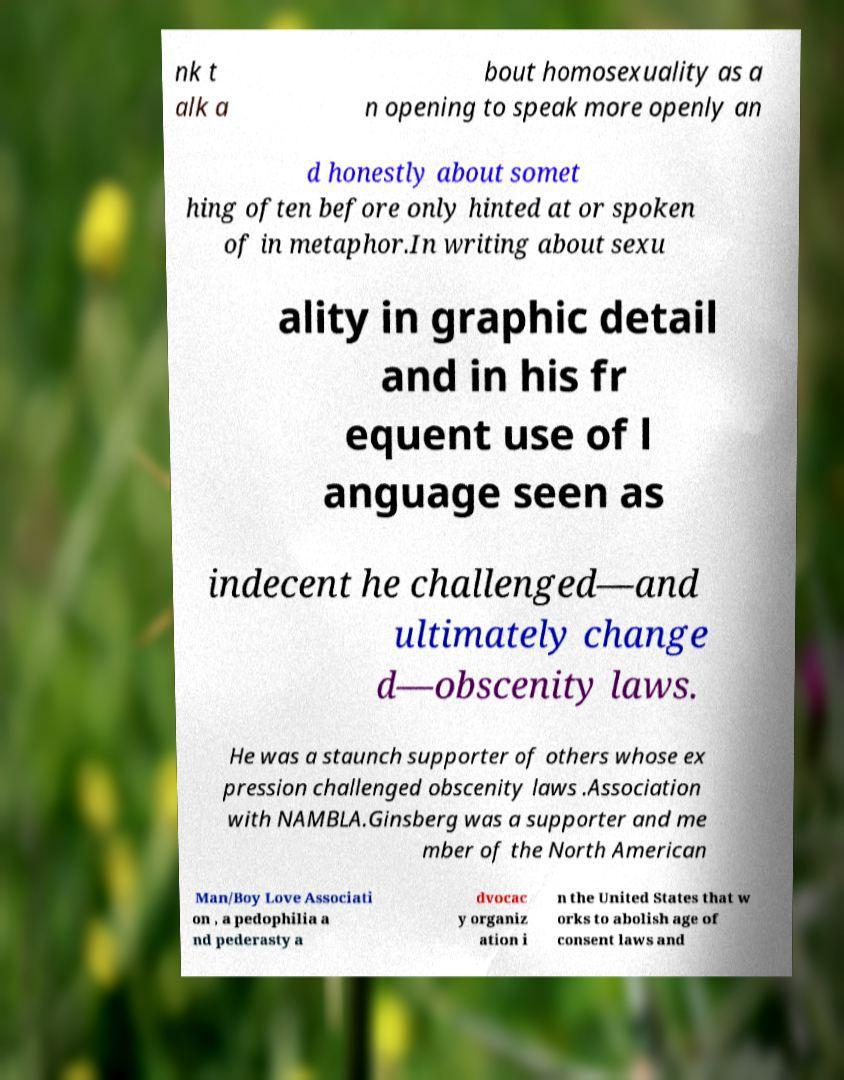Could you extract and type out the text from this image? nk t alk a bout homosexuality as a n opening to speak more openly an d honestly about somet hing often before only hinted at or spoken of in metaphor.In writing about sexu ality in graphic detail and in his fr equent use of l anguage seen as indecent he challenged—and ultimately change d—obscenity laws. He was a staunch supporter of others whose ex pression challenged obscenity laws .Association with NAMBLA.Ginsberg was a supporter and me mber of the North American Man/Boy Love Associati on , a pedophilia a nd pederasty a dvocac y organiz ation i n the United States that w orks to abolish age of consent laws and 